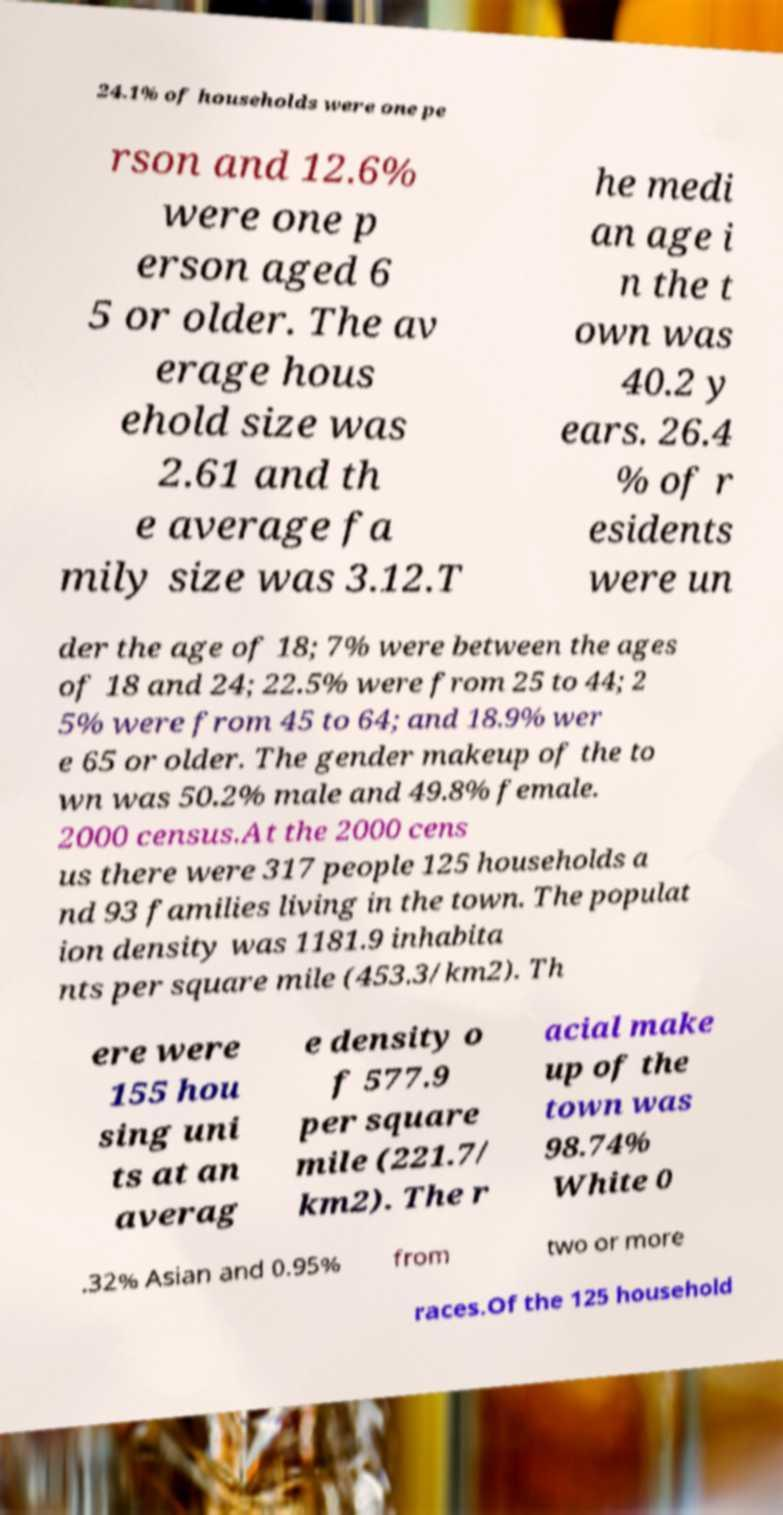Please identify and transcribe the text found in this image. 24.1% of households were one pe rson and 12.6% were one p erson aged 6 5 or older. The av erage hous ehold size was 2.61 and th e average fa mily size was 3.12.T he medi an age i n the t own was 40.2 y ears. 26.4 % of r esidents were un der the age of 18; 7% were between the ages of 18 and 24; 22.5% were from 25 to 44; 2 5% were from 45 to 64; and 18.9% wer e 65 or older. The gender makeup of the to wn was 50.2% male and 49.8% female. 2000 census.At the 2000 cens us there were 317 people 125 households a nd 93 families living in the town. The populat ion density was 1181.9 inhabita nts per square mile (453.3/km2). Th ere were 155 hou sing uni ts at an averag e density o f 577.9 per square mile (221.7/ km2). The r acial make up of the town was 98.74% White 0 .32% Asian and 0.95% from two or more races.Of the 125 household 